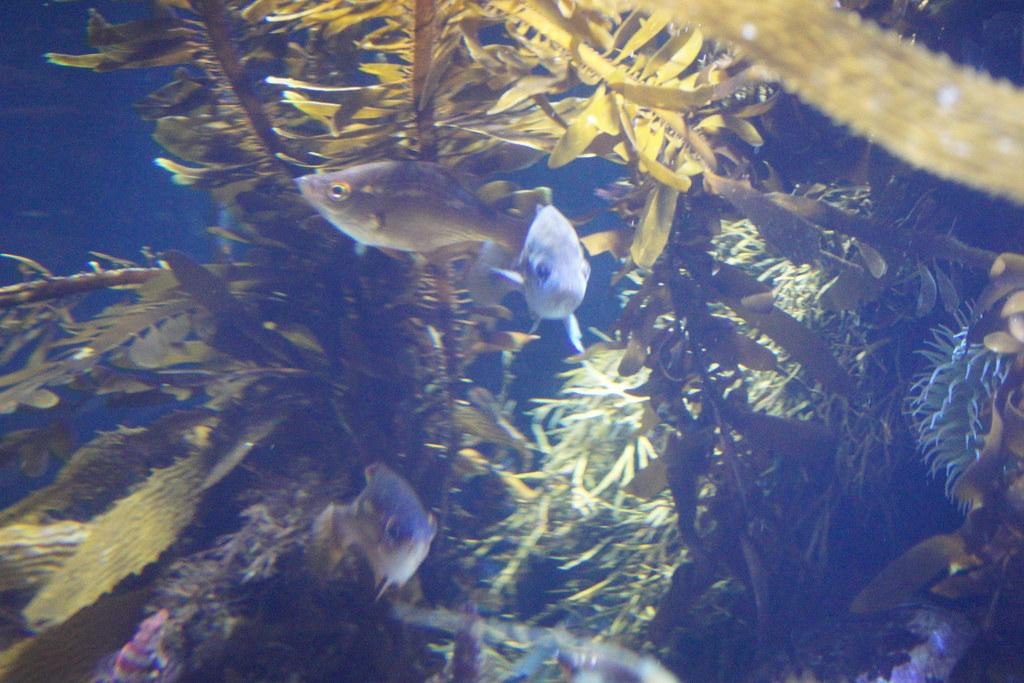What type of animals can be seen in the water? There are fishes in the water. What can be seen behind the fishes? There are plants visible behind the fishes. What type of lamp is hanging above the garden in the image? There is no lamp or garden present in the image; it features fishes in the water with plants in the background. 